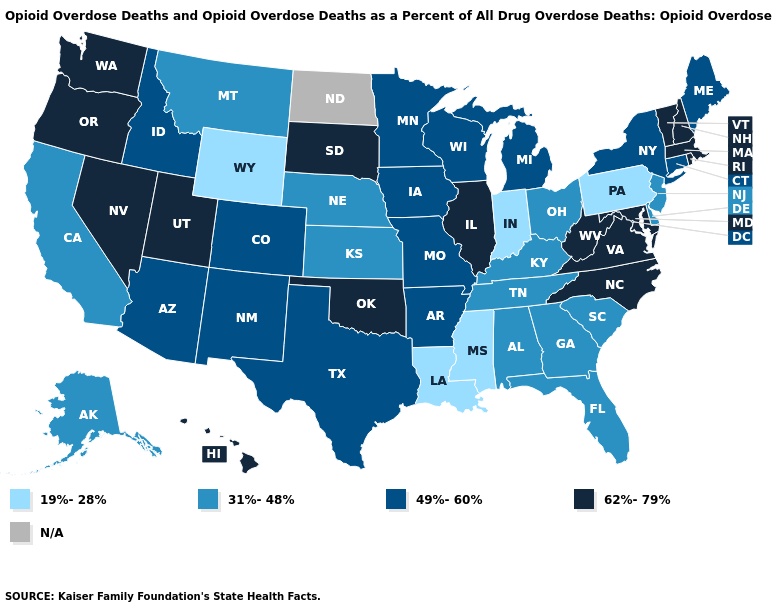What is the value of Nevada?
Be succinct. 62%-79%. Does the first symbol in the legend represent the smallest category?
Concise answer only. Yes. What is the lowest value in the Northeast?
Quick response, please. 19%-28%. What is the lowest value in the USA?
Keep it brief. 19%-28%. Name the states that have a value in the range 49%-60%?
Give a very brief answer. Arizona, Arkansas, Colorado, Connecticut, Idaho, Iowa, Maine, Michigan, Minnesota, Missouri, New Mexico, New York, Texas, Wisconsin. Among the states that border Montana , does Idaho have the lowest value?
Answer briefly. No. Name the states that have a value in the range 19%-28%?
Quick response, please. Indiana, Louisiana, Mississippi, Pennsylvania, Wyoming. Does the first symbol in the legend represent the smallest category?
Write a very short answer. Yes. Does South Dakota have the highest value in the MidWest?
Concise answer only. Yes. Which states have the highest value in the USA?
Short answer required. Hawaii, Illinois, Maryland, Massachusetts, Nevada, New Hampshire, North Carolina, Oklahoma, Oregon, Rhode Island, South Dakota, Utah, Vermont, Virginia, Washington, West Virginia. What is the highest value in the West ?
Give a very brief answer. 62%-79%. What is the lowest value in states that border Louisiana?
Give a very brief answer. 19%-28%. Does Minnesota have the lowest value in the USA?
Short answer required. No. Which states have the lowest value in the USA?
Give a very brief answer. Indiana, Louisiana, Mississippi, Pennsylvania, Wyoming. 